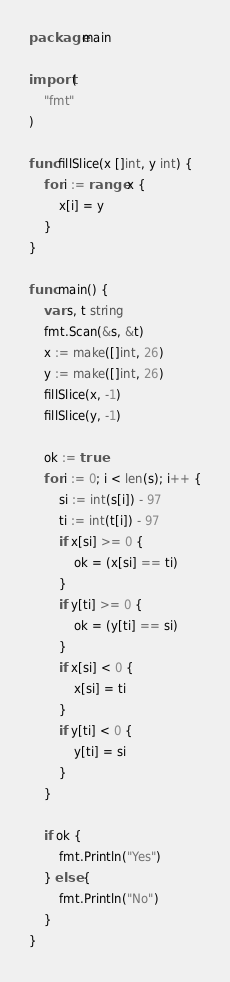Convert code to text. <code><loc_0><loc_0><loc_500><loc_500><_Go_>package main

import (
	"fmt"
)

func fillSlice(x []int, y int) {
	for i := range x {
		x[i] = y
	}
}

func main() {
	var s, t string
	fmt.Scan(&s, &t)
	x := make([]int, 26)
	y := make([]int, 26)
	fillSlice(x, -1)
	fillSlice(y, -1)

	ok := true
	for i := 0; i < len(s); i++ {
		si := int(s[i]) - 97
		ti := int(t[i]) - 97
		if x[si] >= 0 {
			ok = (x[si] == ti)
		}
		if y[ti] >= 0 {
			ok = (y[ti] == si)
		}
		if x[si] < 0 {
			x[si] = ti
		}
		if y[ti] < 0 {
			y[ti] = si
		}
	}

	if ok {
		fmt.Println("Yes")
	} else {
		fmt.Println("No")
	}
}
</code> 